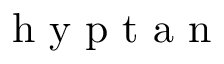Convert formula to latex. <formula><loc_0><loc_0><loc_500><loc_500>h y p t a n</formula> 